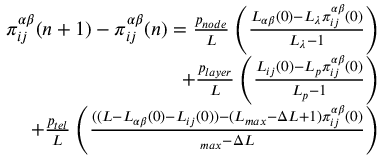<formula> <loc_0><loc_0><loc_500><loc_500>\begin{array} { r } { \pi _ { i j } ^ { \alpha \beta } ( n + 1 ) - \pi _ { i j } ^ { \alpha \beta } ( n ) = \frac { p _ { n o d e } } { L } \left ( \frac { L _ { \alpha \beta } ( 0 ) - L _ { \lambda } \pi _ { i j } ^ { \alpha \beta } ( 0 ) } { L _ { \lambda } - 1 } \right ) } \\ { + \frac { p _ { l a y e r } } { L } \left ( \frac { L _ { i j } ( 0 ) - L _ { p } \pi _ { i j } ^ { \alpha \beta } ( 0 ) } { L _ { p } - 1 } \right ) } \\ { + \frac { p _ { t e l } } { L } \left ( \frac { ( ( L - L _ { \alpha \beta } ( 0 ) - L _ { i j } ( 0 ) ) - ( L _ { \max } - \Delta L + 1 ) \pi _ { i j } ^ { \alpha \beta } ( 0 ) } { \L _ { \max } - \Delta L } \right ) } \end{array}</formula> 